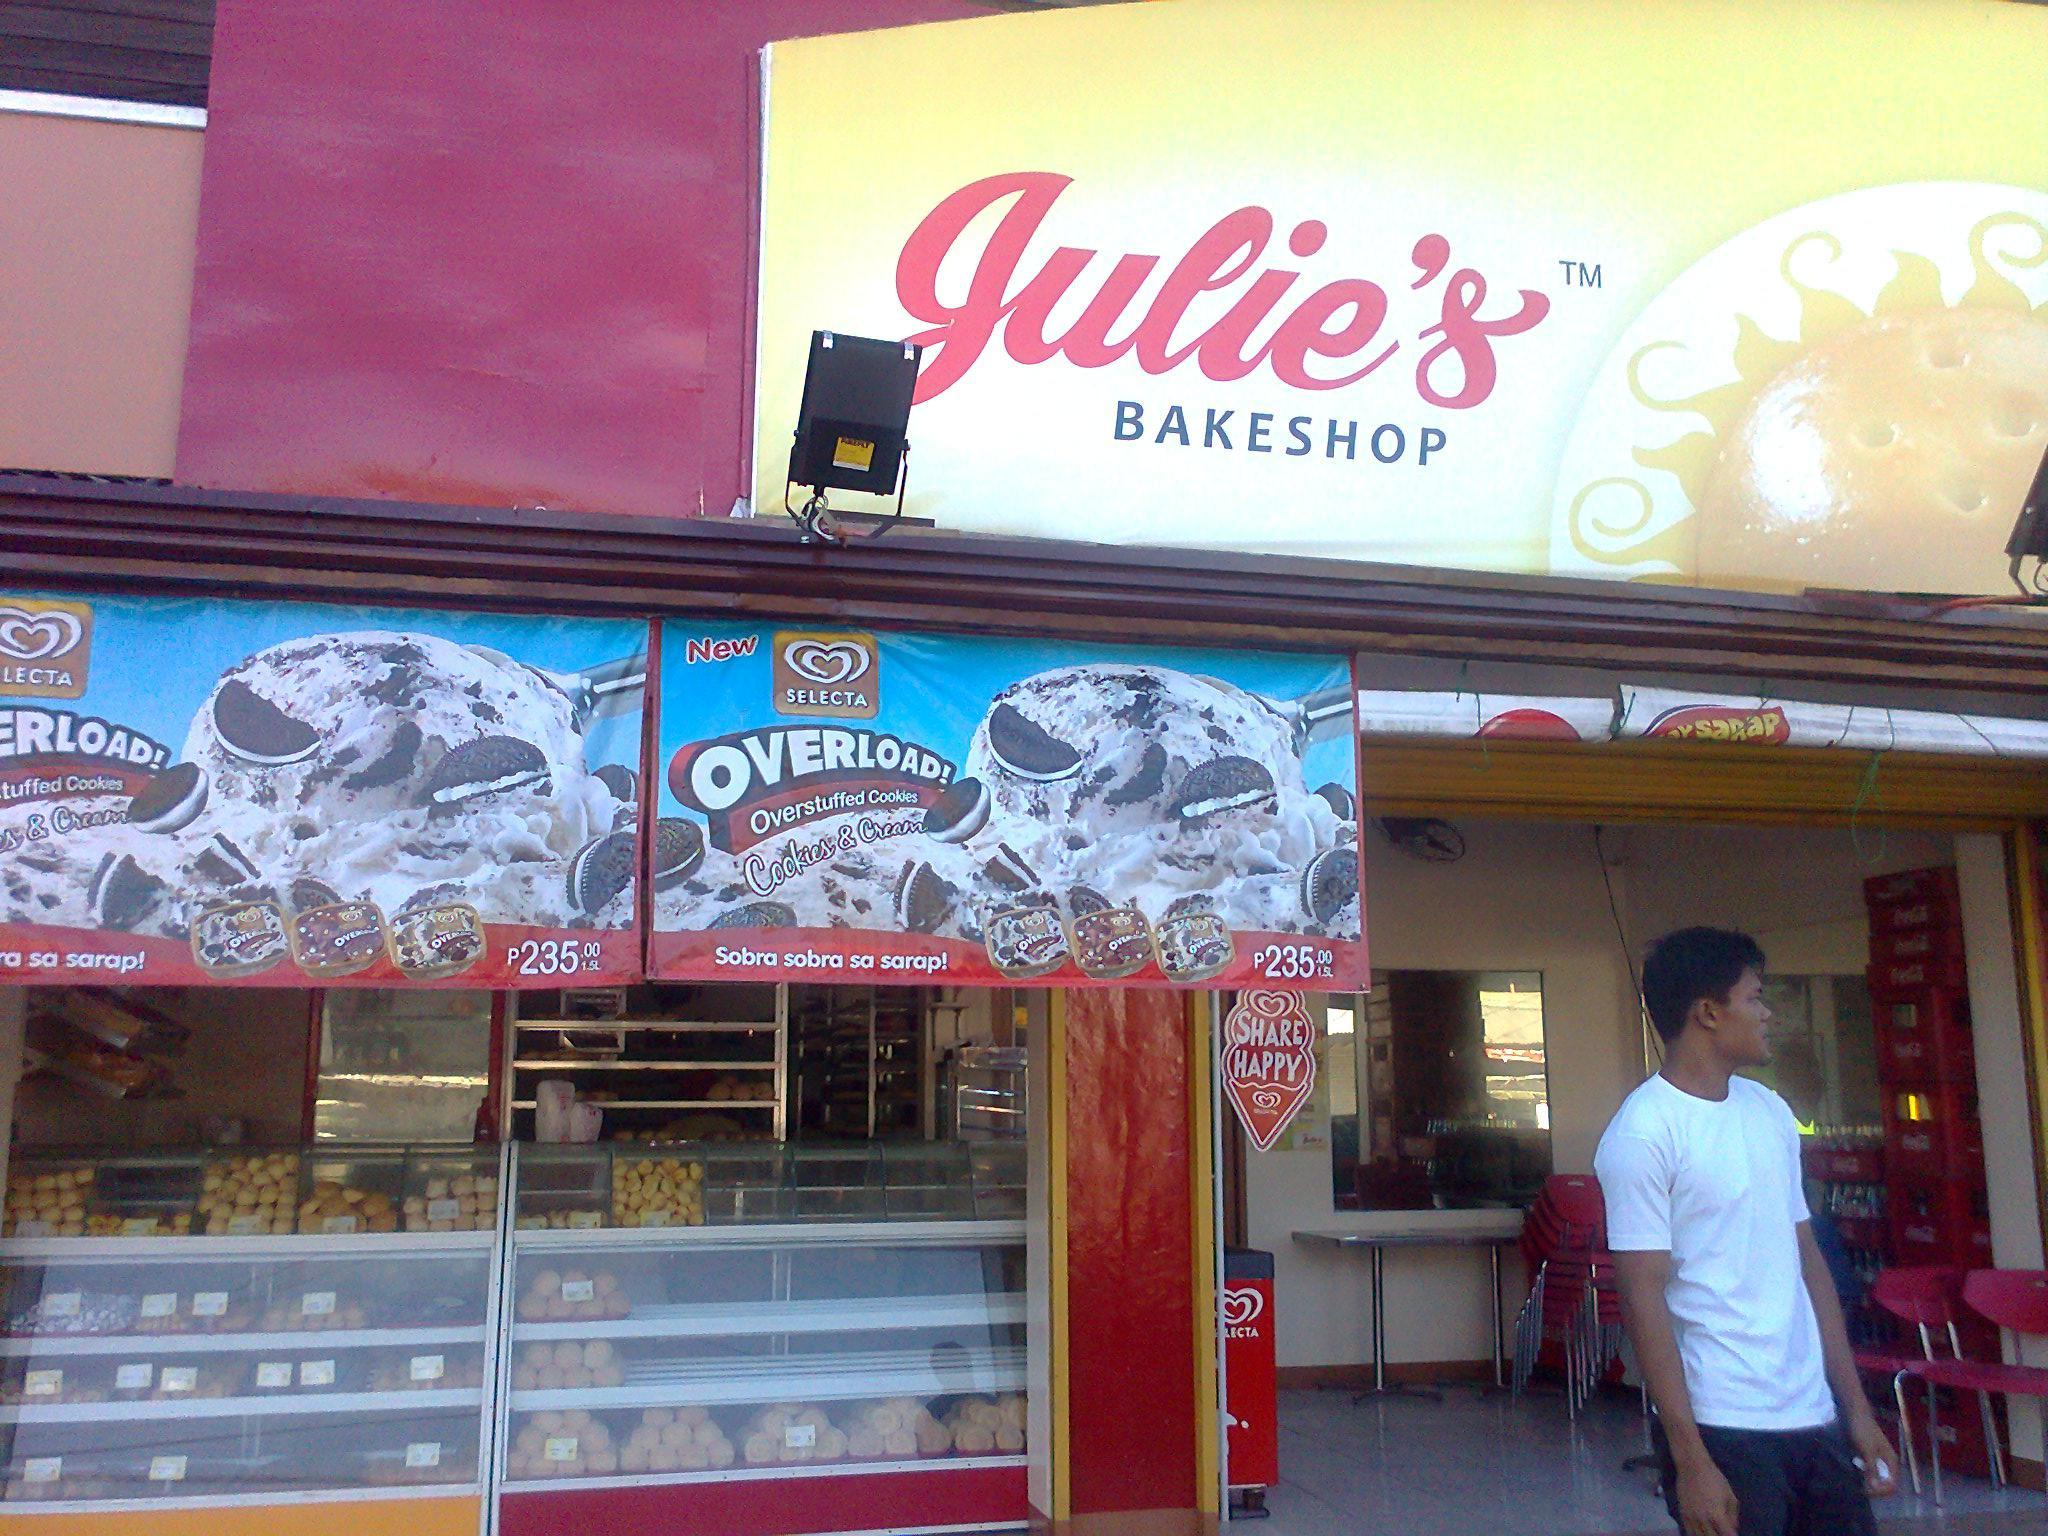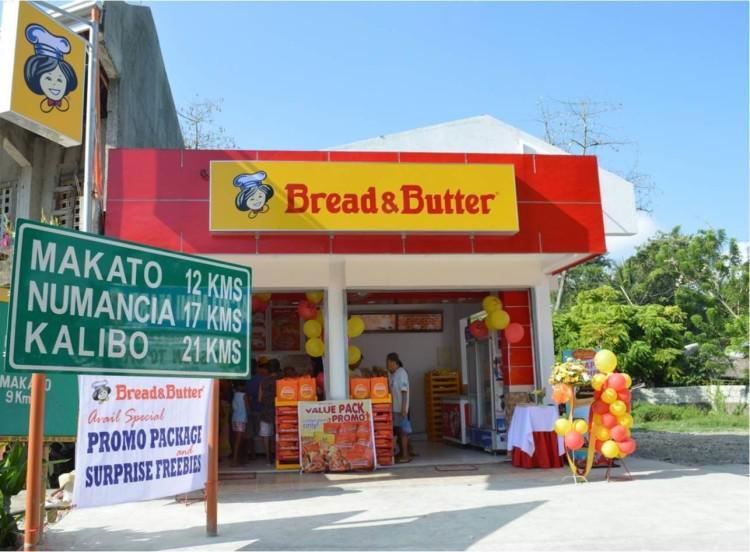The first image is the image on the left, the second image is the image on the right. Assess this claim about the two images: "The right image shows an open-front shop with a yellow sign featuring a cartoon chef face on a red facade, and red and yellow balloons reaching as high as the doorway.". Correct or not? Answer yes or no. Yes. 